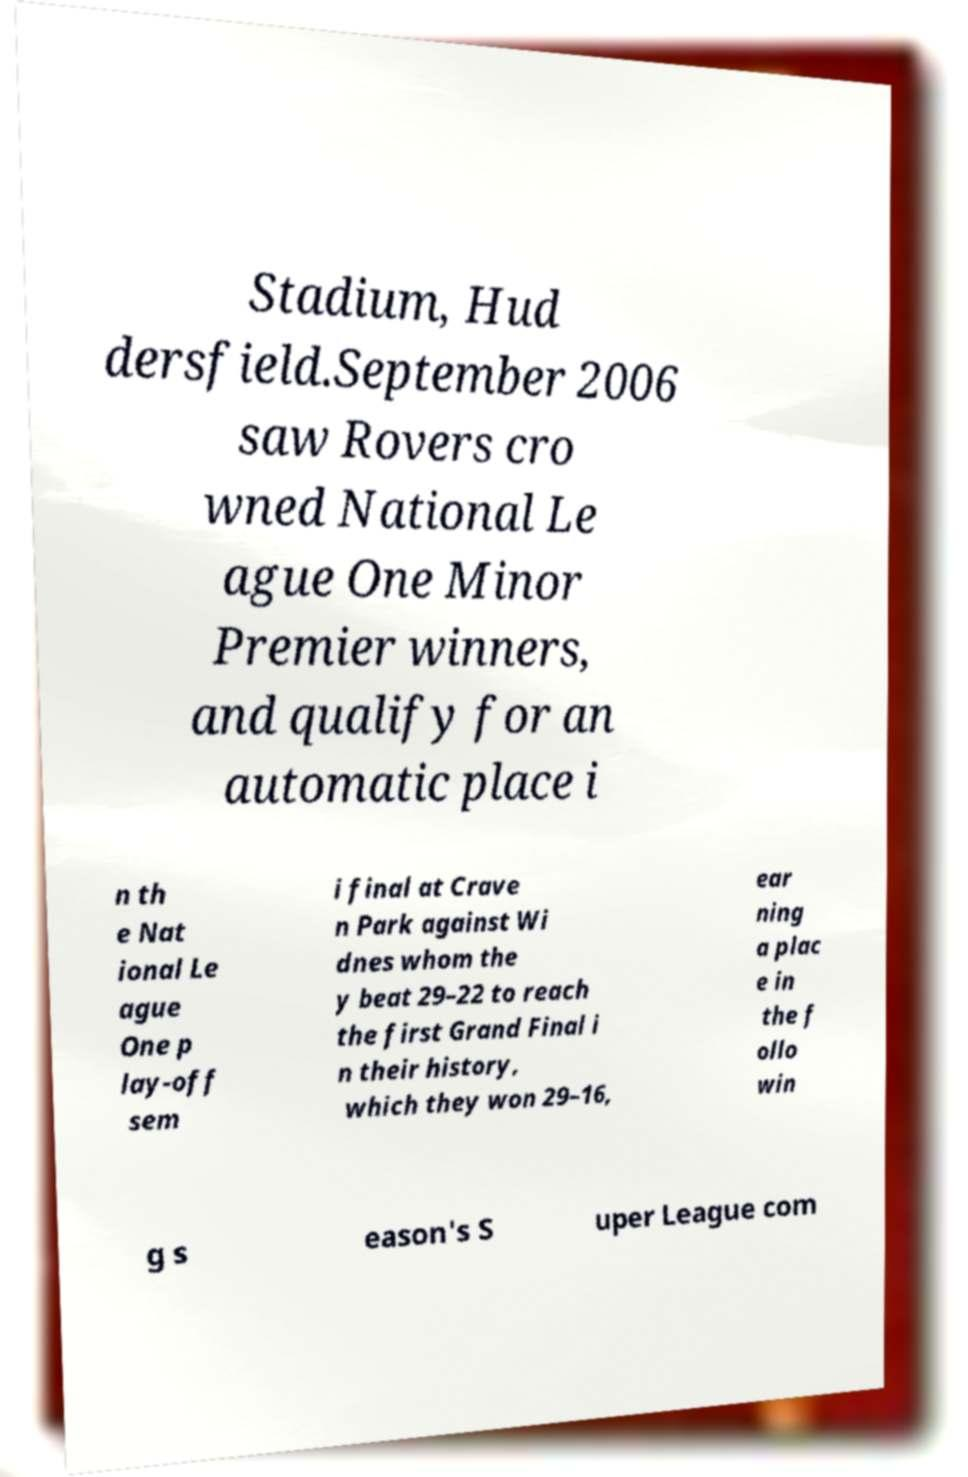What messages or text are displayed in this image? I need them in a readable, typed format. Stadium, Hud dersfield.September 2006 saw Rovers cro wned National Le ague One Minor Premier winners, and qualify for an automatic place i n th e Nat ional Le ague One p lay-off sem i final at Crave n Park against Wi dnes whom the y beat 29–22 to reach the first Grand Final i n their history, which they won 29–16, ear ning a plac e in the f ollo win g s eason's S uper League com 